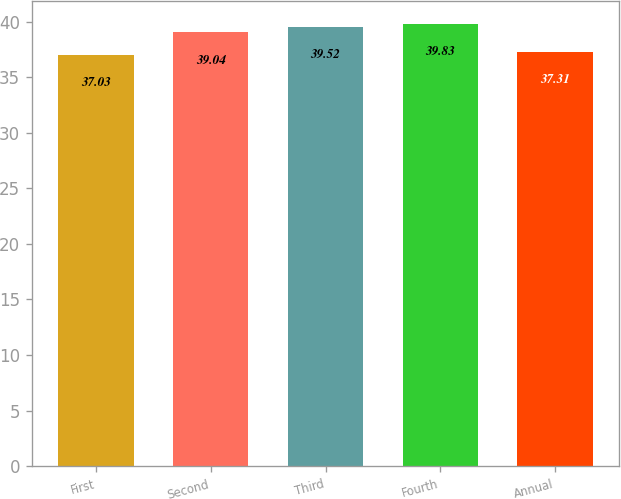Convert chart to OTSL. <chart><loc_0><loc_0><loc_500><loc_500><bar_chart><fcel>First<fcel>Second<fcel>Third<fcel>Fourth<fcel>Annual<nl><fcel>37.03<fcel>39.04<fcel>39.52<fcel>39.83<fcel>37.31<nl></chart> 